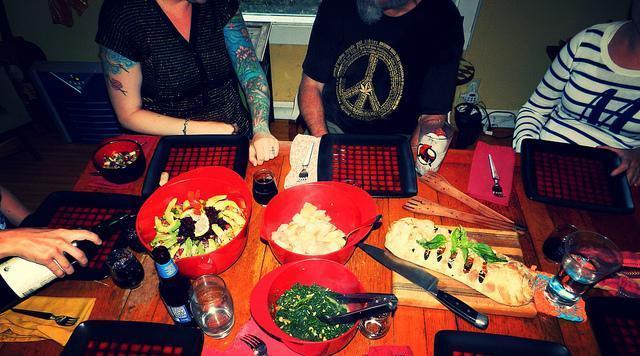How many bowls are visible?
Give a very brief answer. 3. How many people can be seen?
Give a very brief answer. 4. 